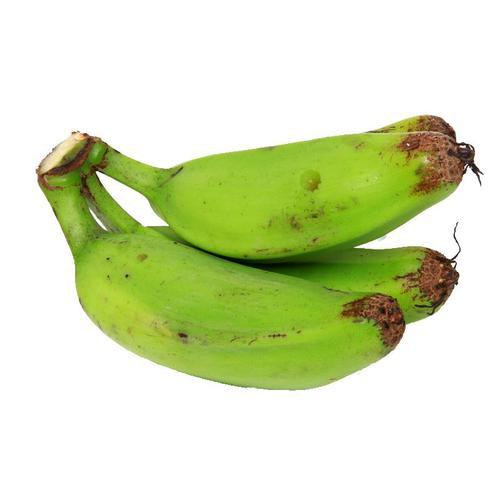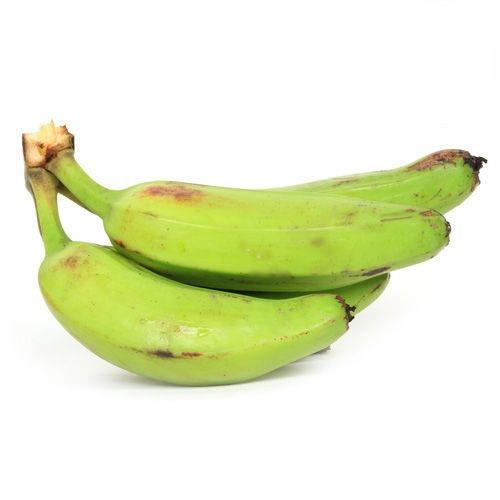The first image is the image on the left, the second image is the image on the right. For the images displayed, is the sentence "The ends of the bananas in both pictures are pointing in opposite directions." factually correct? Answer yes or no. No. The first image is the image on the left, the second image is the image on the right. Considering the images on both sides, is "The left image has at least one banana with it's end facing left, and the right image has a bunch of bananas with it's end facing right." valid? Answer yes or no. No. 